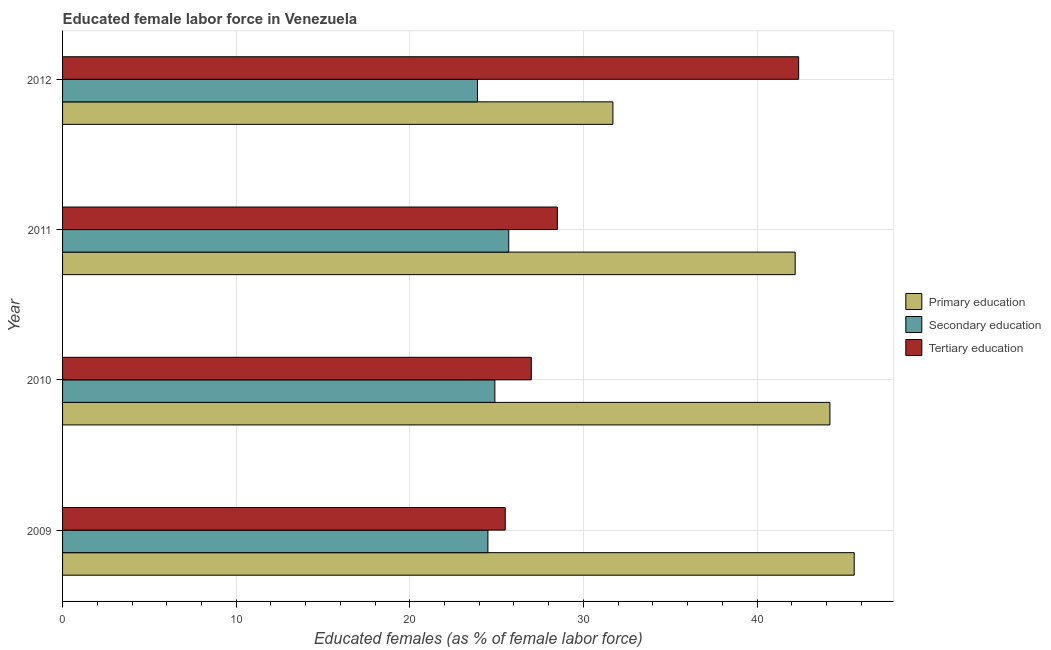How many different coloured bars are there?
Your answer should be compact. 3. How many groups of bars are there?
Offer a terse response. 4. Are the number of bars on each tick of the Y-axis equal?
Ensure brevity in your answer.  Yes. How many bars are there on the 2nd tick from the top?
Provide a short and direct response. 3. How many bars are there on the 2nd tick from the bottom?
Provide a succinct answer. 3. What is the label of the 1st group of bars from the top?
Your answer should be compact. 2012. What is the percentage of female labor force who received secondary education in 2012?
Your response must be concise. 23.9. Across all years, what is the maximum percentage of female labor force who received primary education?
Make the answer very short. 45.6. What is the total percentage of female labor force who received secondary education in the graph?
Your answer should be very brief. 99. What is the difference between the percentage of female labor force who received secondary education in 2011 and the percentage of female labor force who received tertiary education in 2010?
Offer a terse response. -1.3. What is the average percentage of female labor force who received primary education per year?
Your answer should be very brief. 40.92. In the year 2010, what is the difference between the percentage of female labor force who received secondary education and percentage of female labor force who received primary education?
Your response must be concise. -19.3. What is the ratio of the percentage of female labor force who received secondary education in 2011 to that in 2012?
Your response must be concise. 1.07. In how many years, is the percentage of female labor force who received primary education greater than the average percentage of female labor force who received primary education taken over all years?
Make the answer very short. 3. Is the sum of the percentage of female labor force who received secondary education in 2009 and 2012 greater than the maximum percentage of female labor force who received tertiary education across all years?
Give a very brief answer. Yes. What does the 1st bar from the top in 2009 represents?
Offer a terse response. Tertiary education. What does the 2nd bar from the bottom in 2010 represents?
Your answer should be very brief. Secondary education. How many years are there in the graph?
Provide a short and direct response. 4. Are the values on the major ticks of X-axis written in scientific E-notation?
Provide a short and direct response. No. Does the graph contain any zero values?
Your answer should be compact. No. How many legend labels are there?
Ensure brevity in your answer.  3. How are the legend labels stacked?
Provide a succinct answer. Vertical. What is the title of the graph?
Your response must be concise. Educated female labor force in Venezuela. What is the label or title of the X-axis?
Make the answer very short. Educated females (as % of female labor force). What is the label or title of the Y-axis?
Offer a very short reply. Year. What is the Educated females (as % of female labor force) of Primary education in 2009?
Your answer should be very brief. 45.6. What is the Educated females (as % of female labor force) in Primary education in 2010?
Provide a succinct answer. 44.2. What is the Educated females (as % of female labor force) of Secondary education in 2010?
Your response must be concise. 24.9. What is the Educated females (as % of female labor force) in Primary education in 2011?
Your answer should be compact. 42.2. What is the Educated females (as % of female labor force) of Secondary education in 2011?
Your response must be concise. 25.7. What is the Educated females (as % of female labor force) of Primary education in 2012?
Your answer should be very brief. 31.7. What is the Educated females (as % of female labor force) of Secondary education in 2012?
Offer a very short reply. 23.9. What is the Educated females (as % of female labor force) in Tertiary education in 2012?
Keep it short and to the point. 42.4. Across all years, what is the maximum Educated females (as % of female labor force) of Primary education?
Ensure brevity in your answer.  45.6. Across all years, what is the maximum Educated females (as % of female labor force) in Secondary education?
Offer a terse response. 25.7. Across all years, what is the maximum Educated females (as % of female labor force) in Tertiary education?
Keep it short and to the point. 42.4. Across all years, what is the minimum Educated females (as % of female labor force) in Primary education?
Keep it short and to the point. 31.7. Across all years, what is the minimum Educated females (as % of female labor force) in Secondary education?
Your response must be concise. 23.9. Across all years, what is the minimum Educated females (as % of female labor force) of Tertiary education?
Make the answer very short. 25.5. What is the total Educated females (as % of female labor force) in Primary education in the graph?
Offer a very short reply. 163.7. What is the total Educated females (as % of female labor force) in Secondary education in the graph?
Your answer should be compact. 99. What is the total Educated females (as % of female labor force) of Tertiary education in the graph?
Ensure brevity in your answer.  123.4. What is the difference between the Educated females (as % of female labor force) in Primary education in 2009 and that in 2011?
Provide a succinct answer. 3.4. What is the difference between the Educated females (as % of female labor force) of Tertiary education in 2009 and that in 2012?
Offer a very short reply. -16.9. What is the difference between the Educated females (as % of female labor force) of Primary education in 2010 and that in 2011?
Make the answer very short. 2. What is the difference between the Educated females (as % of female labor force) in Secondary education in 2010 and that in 2011?
Provide a short and direct response. -0.8. What is the difference between the Educated females (as % of female labor force) of Tertiary education in 2010 and that in 2011?
Ensure brevity in your answer.  -1.5. What is the difference between the Educated females (as % of female labor force) of Primary education in 2010 and that in 2012?
Give a very brief answer. 12.5. What is the difference between the Educated females (as % of female labor force) of Tertiary education in 2010 and that in 2012?
Your answer should be very brief. -15.4. What is the difference between the Educated females (as % of female labor force) in Secondary education in 2011 and that in 2012?
Provide a short and direct response. 1.8. What is the difference between the Educated females (as % of female labor force) in Tertiary education in 2011 and that in 2012?
Offer a very short reply. -13.9. What is the difference between the Educated females (as % of female labor force) in Primary education in 2009 and the Educated females (as % of female labor force) in Secondary education in 2010?
Keep it short and to the point. 20.7. What is the difference between the Educated females (as % of female labor force) of Primary education in 2009 and the Educated females (as % of female labor force) of Tertiary education in 2010?
Make the answer very short. 18.6. What is the difference between the Educated females (as % of female labor force) of Primary education in 2009 and the Educated females (as % of female labor force) of Secondary education in 2011?
Your answer should be compact. 19.9. What is the difference between the Educated females (as % of female labor force) in Primary education in 2009 and the Educated females (as % of female labor force) in Tertiary education in 2011?
Your response must be concise. 17.1. What is the difference between the Educated females (as % of female labor force) of Primary education in 2009 and the Educated females (as % of female labor force) of Secondary education in 2012?
Provide a short and direct response. 21.7. What is the difference between the Educated females (as % of female labor force) of Secondary education in 2009 and the Educated females (as % of female labor force) of Tertiary education in 2012?
Offer a terse response. -17.9. What is the difference between the Educated females (as % of female labor force) in Primary education in 2010 and the Educated females (as % of female labor force) in Secondary education in 2011?
Your answer should be compact. 18.5. What is the difference between the Educated females (as % of female labor force) in Secondary education in 2010 and the Educated females (as % of female labor force) in Tertiary education in 2011?
Your response must be concise. -3.6. What is the difference between the Educated females (as % of female labor force) of Primary education in 2010 and the Educated females (as % of female labor force) of Secondary education in 2012?
Ensure brevity in your answer.  20.3. What is the difference between the Educated females (as % of female labor force) of Primary education in 2010 and the Educated females (as % of female labor force) of Tertiary education in 2012?
Offer a very short reply. 1.8. What is the difference between the Educated females (as % of female labor force) of Secondary education in 2010 and the Educated females (as % of female labor force) of Tertiary education in 2012?
Your answer should be compact. -17.5. What is the difference between the Educated females (as % of female labor force) of Secondary education in 2011 and the Educated females (as % of female labor force) of Tertiary education in 2012?
Keep it short and to the point. -16.7. What is the average Educated females (as % of female labor force) in Primary education per year?
Your response must be concise. 40.92. What is the average Educated females (as % of female labor force) of Secondary education per year?
Make the answer very short. 24.75. What is the average Educated females (as % of female labor force) of Tertiary education per year?
Offer a terse response. 30.85. In the year 2009, what is the difference between the Educated females (as % of female labor force) of Primary education and Educated females (as % of female labor force) of Secondary education?
Your answer should be compact. 21.1. In the year 2009, what is the difference between the Educated females (as % of female labor force) in Primary education and Educated females (as % of female labor force) in Tertiary education?
Your answer should be compact. 20.1. In the year 2009, what is the difference between the Educated females (as % of female labor force) in Secondary education and Educated females (as % of female labor force) in Tertiary education?
Provide a short and direct response. -1. In the year 2010, what is the difference between the Educated females (as % of female labor force) in Primary education and Educated females (as % of female labor force) in Secondary education?
Give a very brief answer. 19.3. In the year 2010, what is the difference between the Educated females (as % of female labor force) in Secondary education and Educated females (as % of female labor force) in Tertiary education?
Offer a very short reply. -2.1. In the year 2012, what is the difference between the Educated females (as % of female labor force) in Secondary education and Educated females (as % of female labor force) in Tertiary education?
Provide a succinct answer. -18.5. What is the ratio of the Educated females (as % of female labor force) in Primary education in 2009 to that in 2010?
Keep it short and to the point. 1.03. What is the ratio of the Educated females (as % of female labor force) in Secondary education in 2009 to that in 2010?
Ensure brevity in your answer.  0.98. What is the ratio of the Educated females (as % of female labor force) in Primary education in 2009 to that in 2011?
Your response must be concise. 1.08. What is the ratio of the Educated females (as % of female labor force) in Secondary education in 2009 to that in 2011?
Your answer should be compact. 0.95. What is the ratio of the Educated females (as % of female labor force) of Tertiary education in 2009 to that in 2011?
Make the answer very short. 0.89. What is the ratio of the Educated females (as % of female labor force) in Primary education in 2009 to that in 2012?
Offer a terse response. 1.44. What is the ratio of the Educated females (as % of female labor force) of Secondary education in 2009 to that in 2012?
Give a very brief answer. 1.03. What is the ratio of the Educated females (as % of female labor force) in Tertiary education in 2009 to that in 2012?
Ensure brevity in your answer.  0.6. What is the ratio of the Educated females (as % of female labor force) in Primary education in 2010 to that in 2011?
Your answer should be very brief. 1.05. What is the ratio of the Educated females (as % of female labor force) in Secondary education in 2010 to that in 2011?
Offer a very short reply. 0.97. What is the ratio of the Educated females (as % of female labor force) in Primary education in 2010 to that in 2012?
Offer a very short reply. 1.39. What is the ratio of the Educated females (as % of female labor force) in Secondary education in 2010 to that in 2012?
Keep it short and to the point. 1.04. What is the ratio of the Educated females (as % of female labor force) of Tertiary education in 2010 to that in 2012?
Make the answer very short. 0.64. What is the ratio of the Educated females (as % of female labor force) in Primary education in 2011 to that in 2012?
Make the answer very short. 1.33. What is the ratio of the Educated females (as % of female labor force) of Secondary education in 2011 to that in 2012?
Your response must be concise. 1.08. What is the ratio of the Educated females (as % of female labor force) of Tertiary education in 2011 to that in 2012?
Make the answer very short. 0.67. What is the difference between the highest and the second highest Educated females (as % of female labor force) of Secondary education?
Provide a succinct answer. 0.8. What is the difference between the highest and the second highest Educated females (as % of female labor force) in Tertiary education?
Your response must be concise. 13.9. What is the difference between the highest and the lowest Educated females (as % of female labor force) of Primary education?
Provide a short and direct response. 13.9. What is the difference between the highest and the lowest Educated females (as % of female labor force) of Tertiary education?
Give a very brief answer. 16.9. 